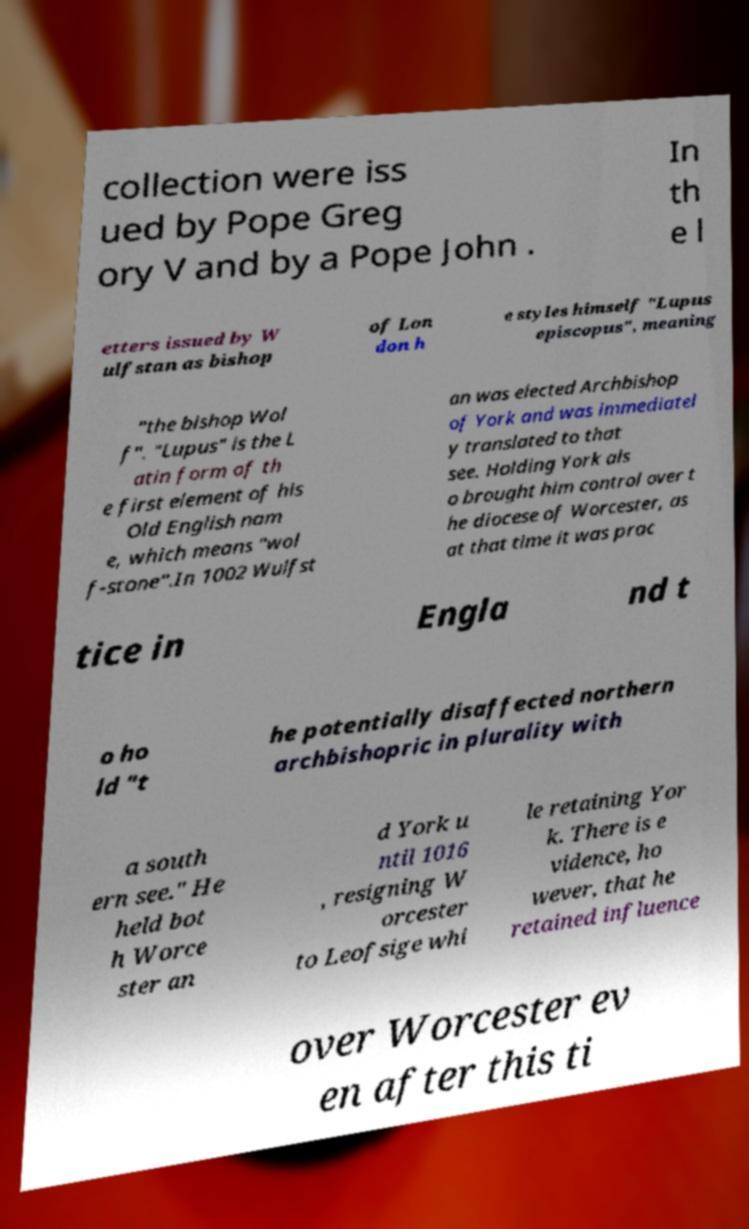For documentation purposes, I need the text within this image transcribed. Could you provide that? collection were iss ued by Pope Greg ory V and by a Pope John . In th e l etters issued by W ulfstan as bishop of Lon don h e styles himself "Lupus episcopus", meaning "the bishop Wol f". "Lupus" is the L atin form of th e first element of his Old English nam e, which means "wol f-stone".In 1002 Wulfst an was elected Archbishop of York and was immediatel y translated to that see. Holding York als o brought him control over t he diocese of Worcester, as at that time it was prac tice in Engla nd t o ho ld "t he potentially disaffected northern archbishopric in plurality with a south ern see." He held bot h Worce ster an d York u ntil 1016 , resigning W orcester to Leofsige whi le retaining Yor k. There is e vidence, ho wever, that he retained influence over Worcester ev en after this ti 